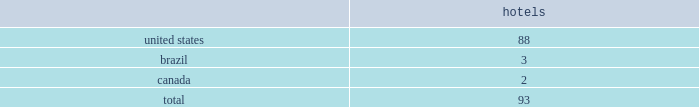Host hotels & resorts , inc. , host hotels & resorts , l.p. , and subsidiaries notes to consolidated financial statements 1 .
Summary of significant accounting policies description of business host hotels & resorts , inc .
Operates as a self-managed and self-administered real estate investment trust , or reit , with its operations conducted solely through host hotels & resorts , l.p .
Host hotels & resorts , l.p. , a delaware limited partnership , operates through an umbrella partnership structure , with host hotels & resorts , inc. , a maryland corporation , as its sole general partner .
In the notes to the consolidated financial statements , we use the terms 201cwe 201d or 201cour 201d to refer to host hotels & resorts , inc .
And host hotels & resorts , l.p .
Together , unless the context indicates otherwise .
We also use the term 201chost inc . 201d to refer specifically to host hotels & resorts , inc .
And the term 201chost l.p . 201d to refer specifically to host hotels & resorts , l.p .
In cases where it is important to distinguish between host inc .
And host l.p .
Host inc .
Holds approximately 99% ( 99 % ) of host l.p . 2019s partnership interests , or op units .
Consolidated portfolio as of december 31 , 2018 , the hotels in our consolidated portfolio are in the following countries: .
Basis of presentation and principles of consolidation the accompanying consolidated financial statements include the consolidated accounts of host inc. , host l.p .
And their subsidiaries and controlled affiliates , including joint ventures and partnerships .
We consolidate subsidiaries when we have the ability to control them .
For the majority of our hotel and real estate investments , we consider those control rights to be ( i ) approval or amendment of developments plans , ( ii ) financing decisions , ( iii ) approval or amendments of operating budgets , and ( iv ) investment strategy decisions .
We also evaluate our subsidiaries to determine if they are variable interest entities ( 201cvies 201d ) .
If a subsidiary is a vie , it is subject to the consolidation framework specifically for vies .
Typically , the entity that has the power to direct the activities that most significantly impact economic performance consolidates the vie .
We consider an entity to be a vie if equity investors own an interest therein that does not have the characteristics of a controlling financial interest or if such investors do not have sufficient equity at risk for the entity to finance its activities without additional subordinated financial support .
We review our subsidiaries and affiliates at least annually to determine if ( i ) they should be considered vies , and ( ii ) whether we should change our consolidation determination based on changes in the characteristics thereof .
Three partnerships are considered vie 2019s , as the general partner maintains control over the decisions that most significantly impact the partnerships .
The first vie is the operating partnership , host l.p. , which is consolidated by host inc. , of which host inc .
Is the general partner and holds 99% ( 99 % ) of the limited partner interests .
Host inc . 2019s sole significant asset is its investment in host l.p .
And substantially all of host inc . 2019s assets and liabilities represent assets and liabilities of host l.p .
All of host inc . 2019s debt is an obligation of host l.p .
And may be settled only with assets of host l.p .
The consolidated partnership that owns the houston airport marriott at george bush intercontinental , of which we are the general partner and hold 85% ( 85 % ) of the partnership interests , also is a vie .
The total assets of this vie at december 31 , 2018 are $ 48 million and consist primarily of cash and .
As of december 31 , 2018what was the percent of the hotels in our consolidated portfolio in the us? 
Computations: (88 / 93)
Answer: 0.94624. 